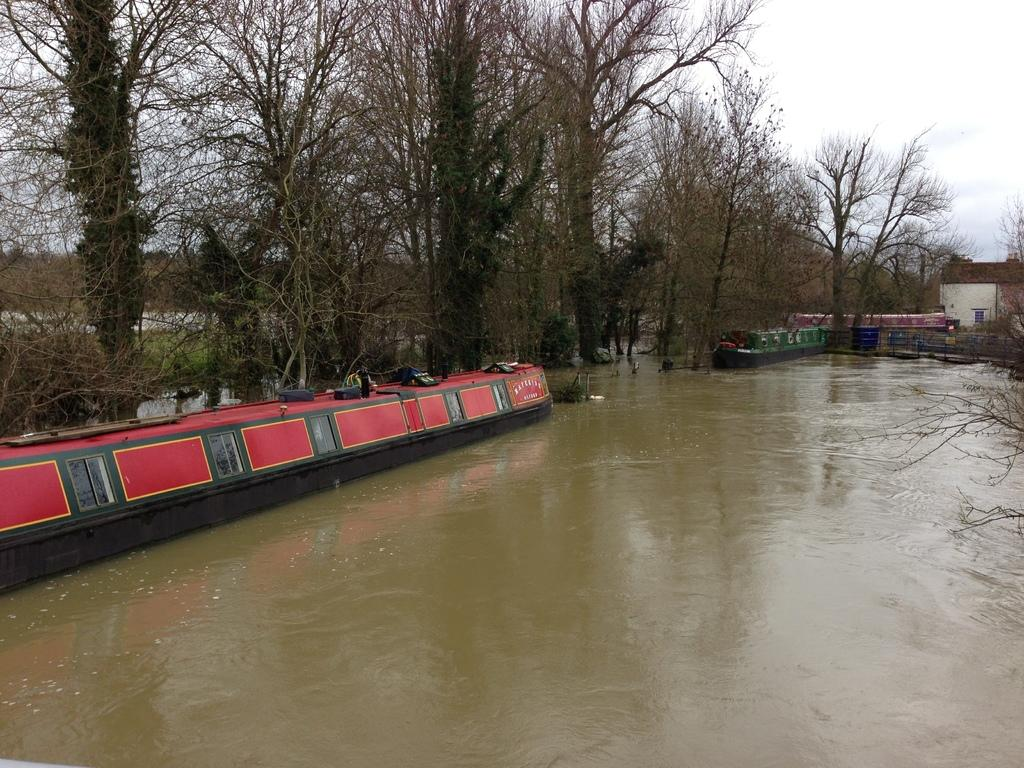What type of vehicles can be seen in the image? There are boats in the image. Where are the boats located? The boats are on the water. What type of natural environment is visible in the image? There are trees in the image. What type of man-made structure is visible in the image? There is a building in the image. What type of pollution can be seen in the image? There is no pollution visible in the image. What type of wine is being served on the boats in the image? There is no wine or indication of any beverages being served in the image. 